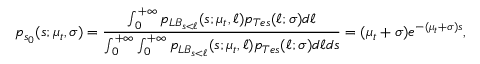Convert formula to latex. <formula><loc_0><loc_0><loc_500><loc_500>p _ { s _ { 0 } } ( s ; \mu _ { t } , \sigma ) = \frac { \int _ { 0 } ^ { + \infty } p _ { L B _ { s < \ell } } ( s ; \mu _ { t } , \ell ) p _ { T e s } ( \ell ; \sigma ) d \ell } { \int _ { 0 } ^ { + \infty } \int _ { 0 } ^ { + \infty } p _ { L B _ { s < \ell } } ( s ; \mu _ { t } , \ell ) p _ { T e s } ( \ell ; \sigma ) d \ell d s } = ( \mu _ { t } + \sigma ) e ^ { - ( \mu _ { t } + \sigma ) s } ,</formula> 